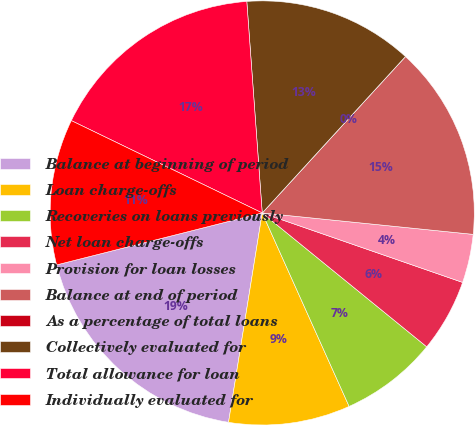Convert chart. <chart><loc_0><loc_0><loc_500><loc_500><pie_chart><fcel>Balance at beginning of period<fcel>Loan charge-offs<fcel>Recoveries on loans previously<fcel>Net loan charge-offs<fcel>Provision for loan losses<fcel>Balance at end of period<fcel>As a percentage of total loans<fcel>Collectively evaluated for<fcel>Total allowance for loan<fcel>Individually evaluated for<nl><fcel>18.52%<fcel>9.26%<fcel>7.41%<fcel>5.56%<fcel>3.7%<fcel>14.81%<fcel>0.0%<fcel>12.96%<fcel>16.67%<fcel>11.11%<nl></chart> 